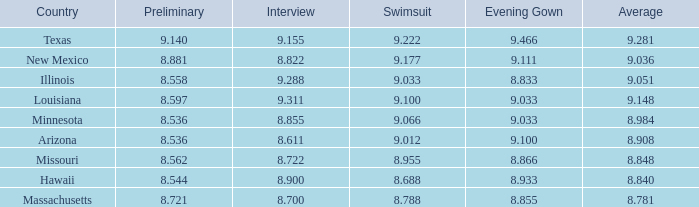What was the swimming costume score for the nation possessing an average rating of 8.955. 